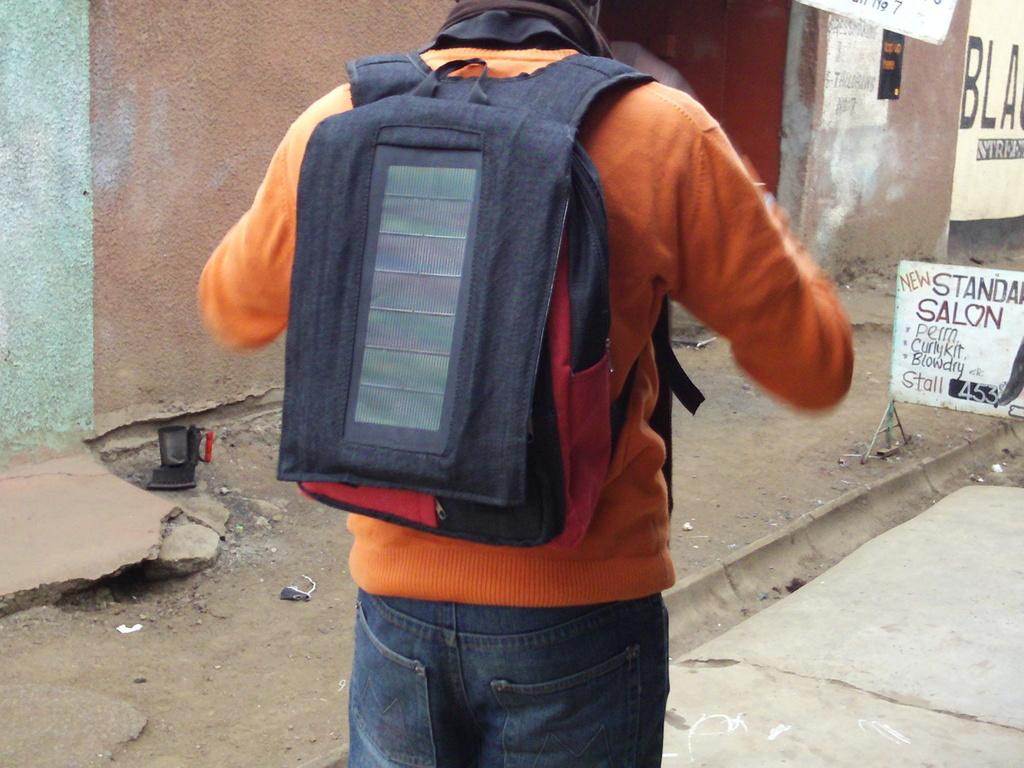<image>
Summarize the visual content of the image. A man with a backpack is standing in front of a sign for a new salon. 